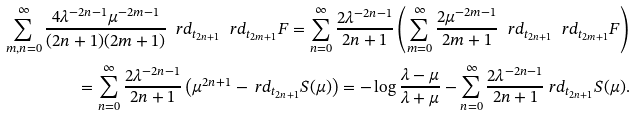Convert formula to latex. <formula><loc_0><loc_0><loc_500><loc_500>\sum _ { m , n = 0 } ^ { \infty } \frac { 4 \lambda ^ { - 2 n - 1 } \mu ^ { - 2 m - 1 } } { ( 2 n + 1 ) ( 2 m + 1 ) } \ r d _ { t _ { 2 n + 1 } } \ r d _ { t _ { 2 m + 1 } } F = \sum _ { n = 0 } ^ { \infty } \frac { 2 \lambda ^ { - 2 n - 1 } } { 2 n + 1 } \left ( \sum _ { m = 0 } ^ { \infty } \frac { 2 \mu ^ { - 2 m - 1 } } { 2 m + 1 } \ r d _ { t _ { 2 n + 1 } } \ r d _ { t _ { 2 m + 1 } } F \right ) \\ = \sum _ { n = 0 } ^ { \infty } \frac { 2 \lambda ^ { - 2 n - 1 } } { 2 n + 1 } \left ( \mu ^ { 2 n + 1 } - \ r d _ { t _ { 2 n + 1 } } S ( \mu ) \right ) = - \log \frac { \lambda - \mu } { \lambda + \mu } - \sum _ { n = 0 } ^ { \infty } \frac { 2 \lambda ^ { - 2 n - 1 } } { 2 n + 1 } \ r d _ { t _ { 2 n + 1 } } S ( \mu ) .</formula> 